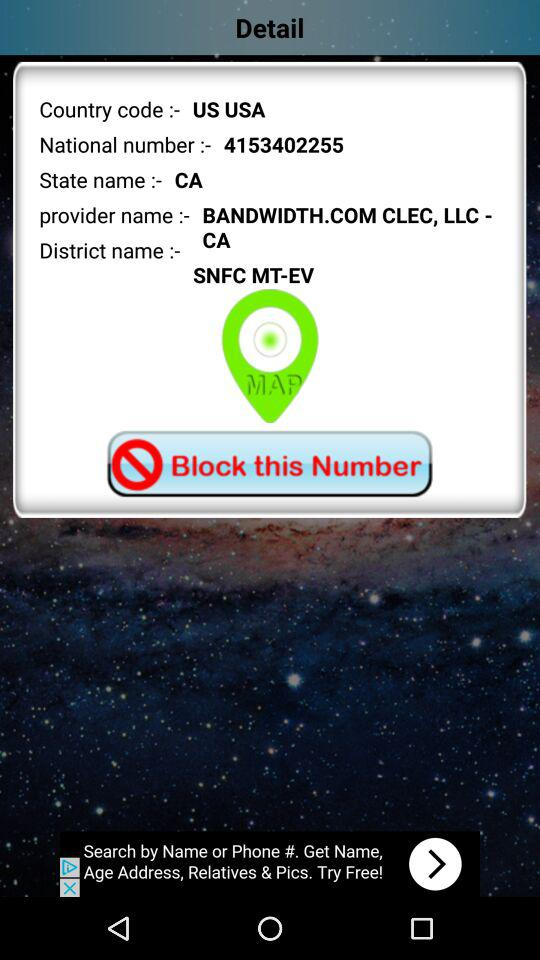What is the country code? The country code is "US USA". 